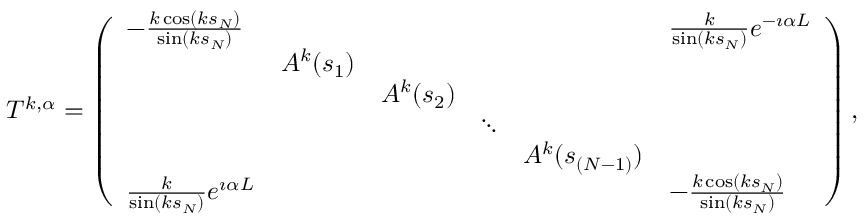<formula> <loc_0><loc_0><loc_500><loc_500>\begin{array} { r } { T ^ { k , \alpha } = \left ( \begin{array} { l l l l l l } { - \frac { k \cos ( k s _ { N } ) } { \sin ( k s _ { N } ) } } & & & & & { \frac { k } { \sin ( k s _ { N } ) } e ^ { - \i \alpha L } } \\ & { A ^ { k } ( s _ { 1 } ) } & & & & \\ & & { A ^ { k } ( s _ { 2 } ) } & & & \\ & & & { \ddots } & & \\ & & & & { A ^ { k } ( s _ { ( N - 1 ) } ) } & \\ { \frac { k } { \sin ( k s _ { N } ) } e ^ { \i \alpha L } } & & & & & { - \frac { k \cos ( k s _ { N } ) } { \sin ( k s _ { N } ) } } \end{array} \right ) , } \end{array}</formula> 